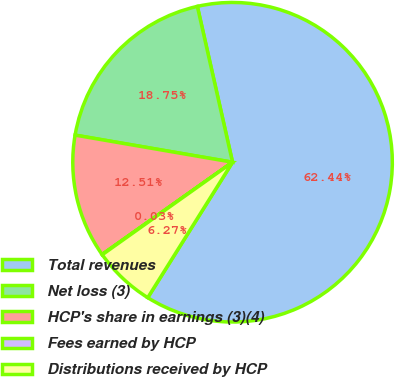Convert chart to OTSL. <chart><loc_0><loc_0><loc_500><loc_500><pie_chart><fcel>Total revenues<fcel>Net loss (3)<fcel>HCP's share in earnings (3)(4)<fcel>Fees earned by HCP<fcel>Distributions received by HCP<nl><fcel>62.44%<fcel>18.75%<fcel>12.51%<fcel>0.03%<fcel>6.27%<nl></chart> 